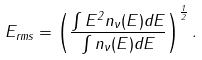<formula> <loc_0><loc_0><loc_500><loc_500>E _ { r m s } = \left ( \frac { \int E ^ { 2 } n _ { \nu } ( E ) d E } { \int n _ { \nu } ( E ) d E } \right ) ^ { \frac { 1 } { 2 } } .</formula> 